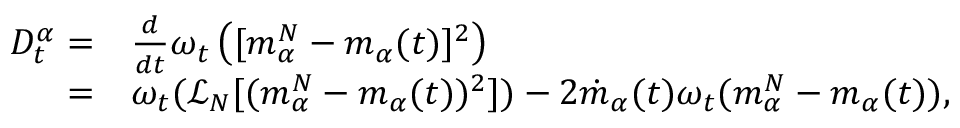<formula> <loc_0><loc_0><loc_500><loc_500>\begin{array} { r l } { D _ { t } ^ { \alpha } = } & { \frac { d } { d t } \omega _ { t } \left ( [ m _ { \alpha } ^ { N } - m _ { \alpha } ( t ) ] ^ { 2 } \right ) } \\ { = } & { \omega _ { t } ( \mathcal { L } _ { N } [ ( m _ { \alpha } ^ { N } - m _ { \alpha } ( t ) ) ^ { 2 } ] ) - 2 \dot { m } _ { \alpha } ( t ) \omega _ { t } ( m _ { \alpha } ^ { N } - m _ { \alpha } ( t ) ) , } \end{array}</formula> 